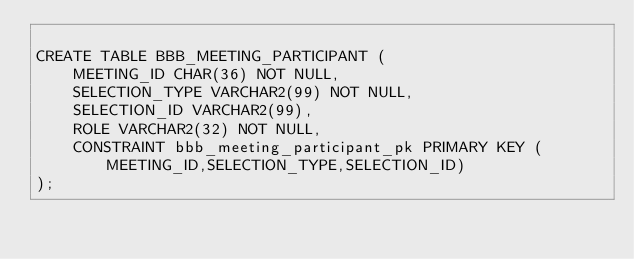<code> <loc_0><loc_0><loc_500><loc_500><_SQL_>
CREATE TABLE BBB_MEETING_PARTICIPANT (
    MEETING_ID CHAR(36) NOT NULL, 
    SELECTION_TYPE VARCHAR2(99) NOT NULL, 
    SELECTION_ID VARCHAR2(99), 
    ROLE VARCHAR2(32) NOT NULL,
    CONSTRAINT bbb_meeting_participant_pk PRIMARY KEY (MEETING_ID,SELECTION_TYPE,SELECTION_ID)
);
</code> 